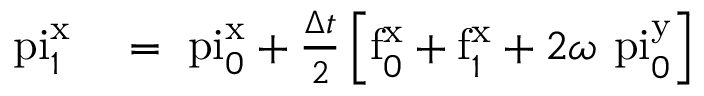<formula> <loc_0><loc_0><loc_500><loc_500>\begin{array} { r l } { \ p i _ { 1 } ^ { x } } & = \ p i _ { 0 } ^ { x } + \frac { \Delta } { 2 } \left [ f _ { 0 } ^ { x } + f _ { 1 } ^ { x } + 2 \omega \ p i _ { 0 } ^ { y } \right ] } \end{array}</formula> 